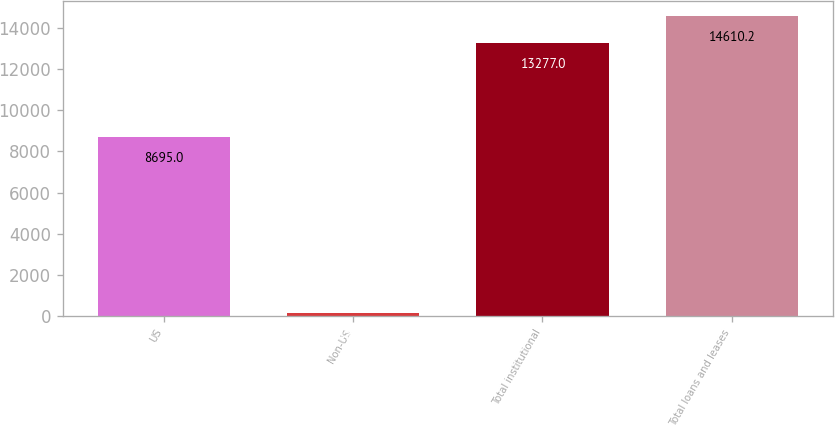Convert chart to OTSL. <chart><loc_0><loc_0><loc_500><loc_500><bar_chart><fcel>US<fcel>Non-US<fcel>Total institutional<fcel>Total loans and leases<nl><fcel>8695<fcel>154<fcel>13277<fcel>14610.2<nl></chart> 